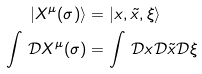Convert formula to latex. <formula><loc_0><loc_0><loc_500><loc_500>| X ^ { \mu } ( \sigma ) \rangle & = | x , \tilde { x } , \xi \rangle \\ \int \, \mathcal { D } X ^ { \mu } ( \sigma ) & = \int \, \mathcal { D } x \mathcal { D } \tilde { x } \mathcal { D } \xi \\</formula> 